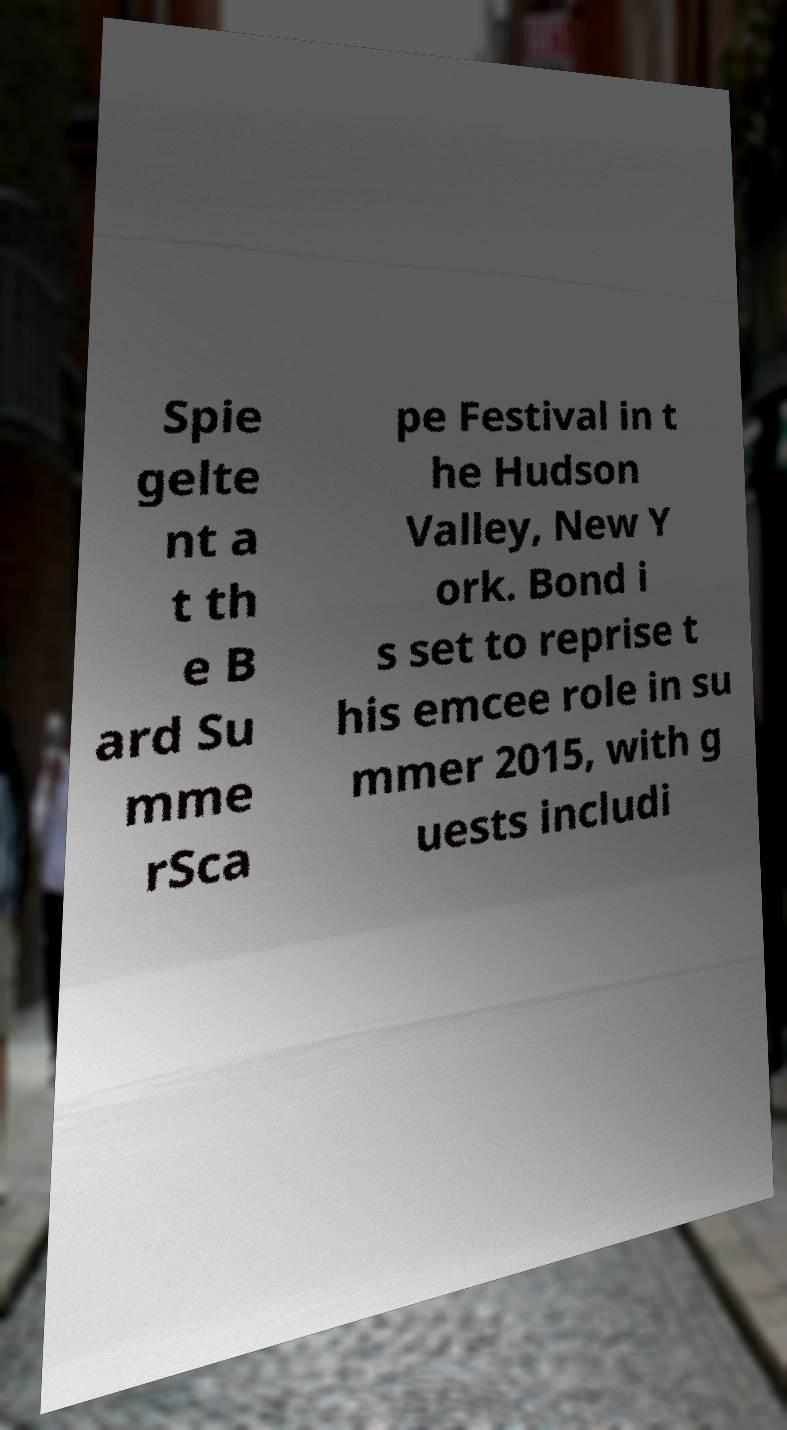Could you extract and type out the text from this image? Spie gelte nt a t th e B ard Su mme rSca pe Festival in t he Hudson Valley, New Y ork. Bond i s set to reprise t his emcee role in su mmer 2015, with g uests includi 